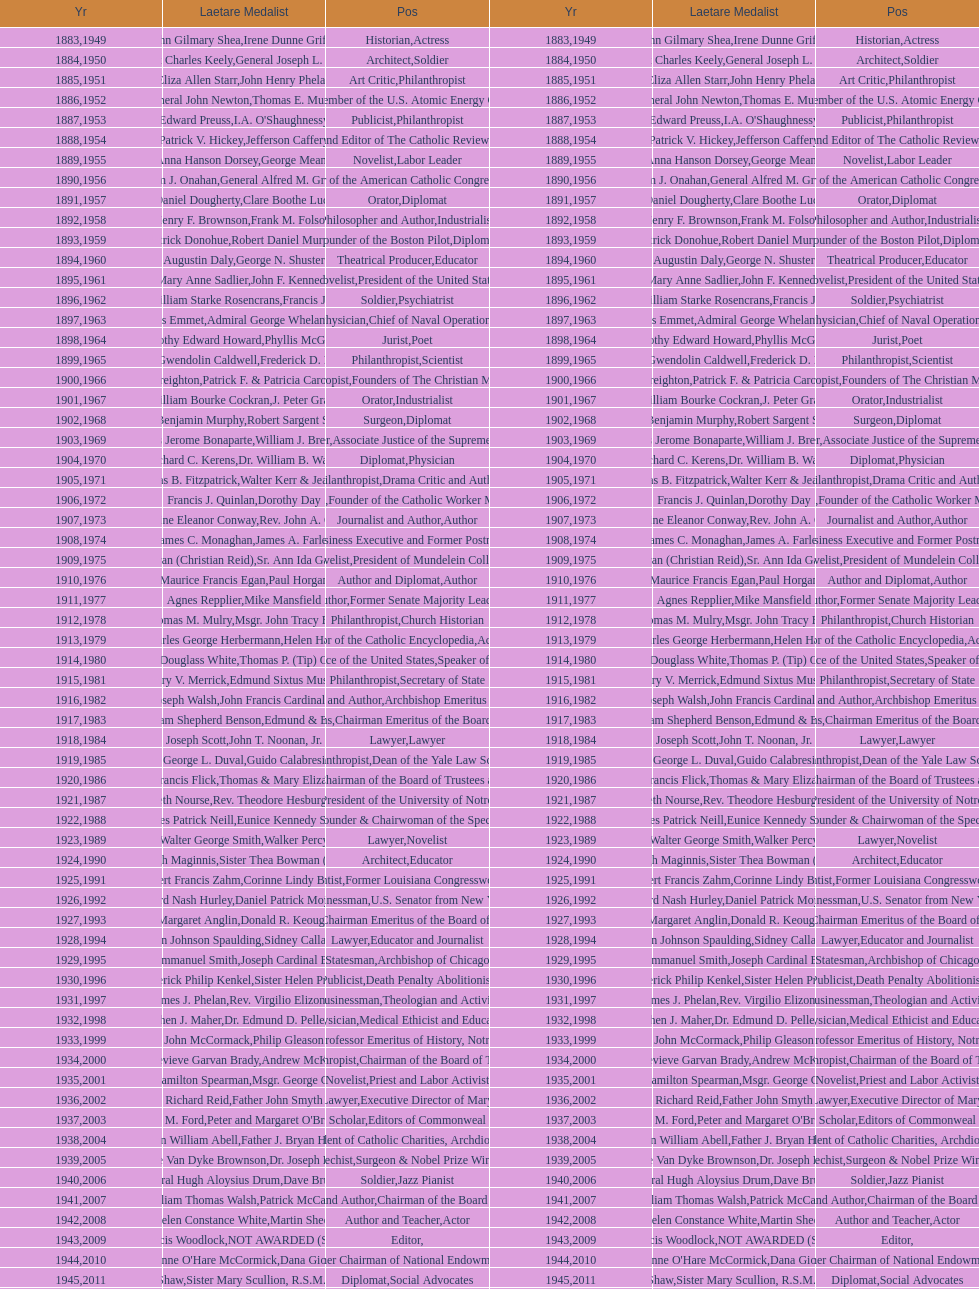How many times does philanthropist appear in the position column on this chart? 9. 